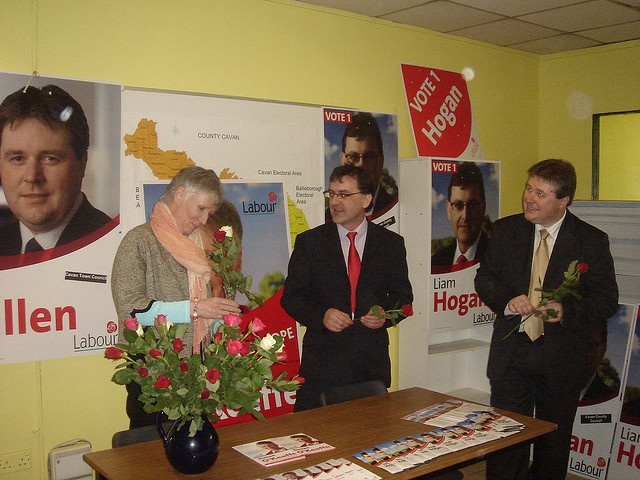Describe the objects in this image and their specific colors. I can see people in tan, black, gray, and olive tones, dining table in tan, maroon, and darkgray tones, people in tan, black, brown, darkgray, and maroon tones, potted plant in tan, darkgreen, black, and maroon tones, and people in tan and gray tones in this image. 